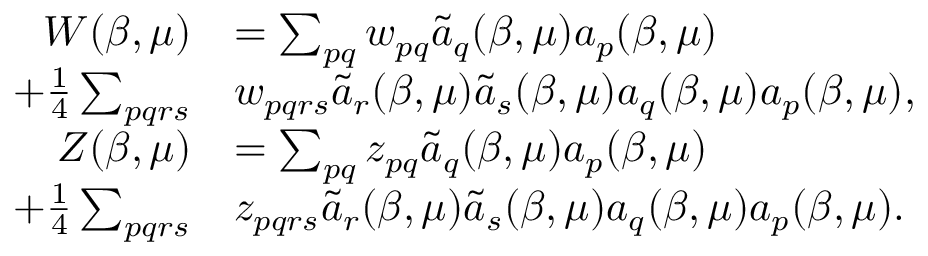<formula> <loc_0><loc_0><loc_500><loc_500>\begin{array} { r l } { W ( \beta , \mu ) } & { = \sum _ { p q } w _ { p q } \tilde { a } _ { q } ( \beta , \mu ) a _ { p } ( \beta , \mu ) } \\ { + \frac { 1 } { 4 } \sum _ { p q r s } } & { w _ { p q r s } \tilde { a } _ { r } ( \beta , \mu ) \tilde { a } _ { s } ( \beta , \mu ) a _ { q } ( \beta , \mu ) a _ { p } ( \beta , \mu ) , } \\ { Z ( \beta , \mu ) } & { = \sum _ { p q } z _ { p q } \tilde { a } _ { q } ( \beta , \mu ) a _ { p } ( \beta , \mu ) } \\ { + \frac { 1 } { 4 } \sum _ { p q r s } } & { z _ { p q r s } \tilde { a } _ { r } ( \beta , \mu ) \tilde { a } _ { s } ( \beta , \mu ) a _ { q } ( \beta , \mu ) a _ { p } ( \beta , \mu ) . } \end{array}</formula> 